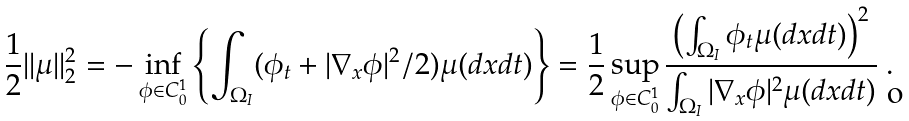<formula> <loc_0><loc_0><loc_500><loc_500>\frac { 1 } { 2 } | | \mu | | ^ { 2 } _ { 2 } = - \inf _ { \phi \in C _ { 0 } ^ { 1 } } \left \{ \int _ { \Omega _ { I } } ( \phi _ { t } + | \nabla _ { x } \phi | ^ { 2 } / 2 ) \mu ( d x d t ) \right \} = \frac { 1 } { 2 } \sup _ { \phi \in C _ { 0 } ^ { 1 } } \frac { \left ( \int _ { \Omega _ { I } } \phi _ { t } \mu ( d x d t ) \right ) ^ { 2 } } { \int _ { \Omega _ { I } } | \nabla _ { x } \phi | ^ { 2 } \mu ( d x d t ) } \ .</formula> 